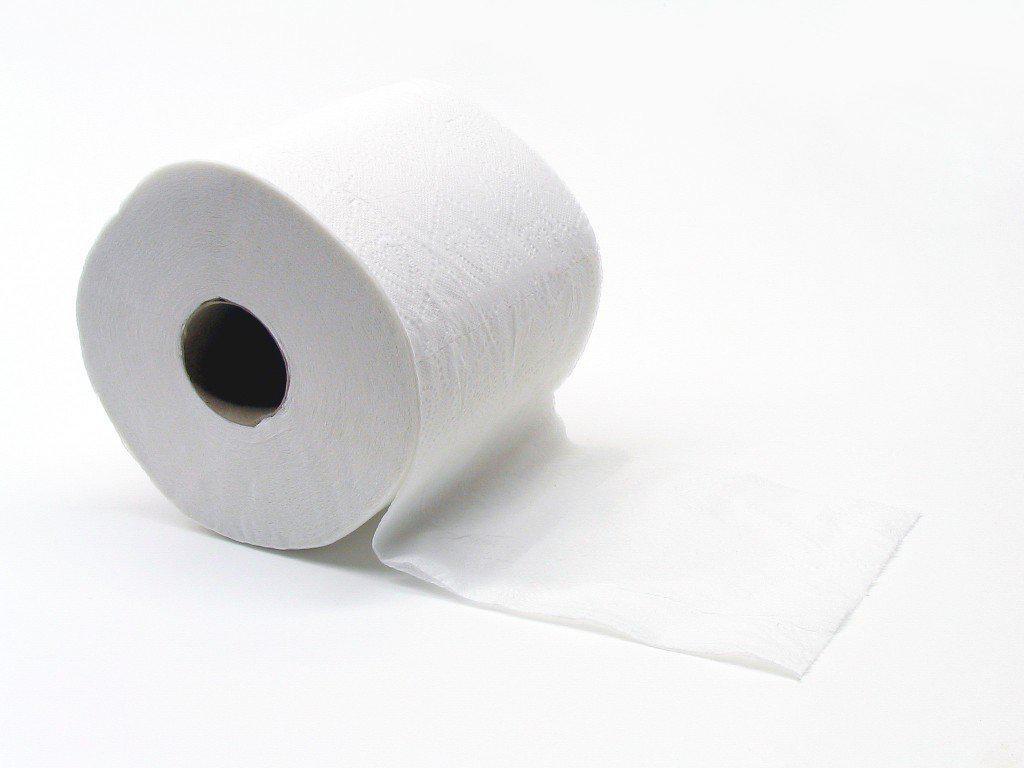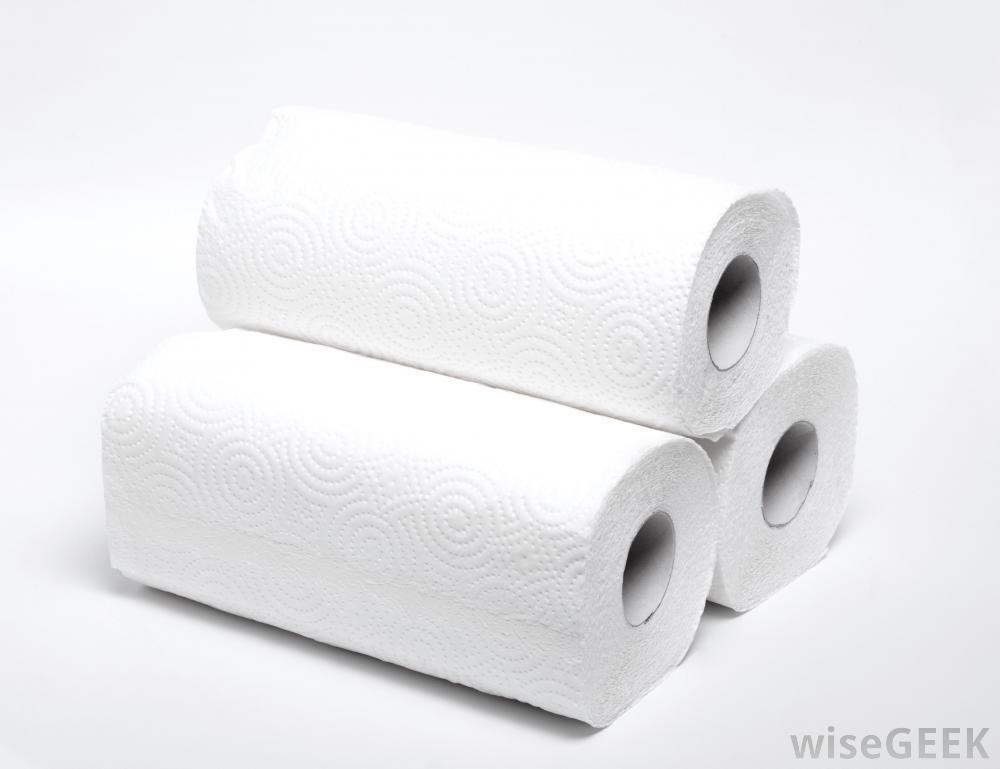The first image is the image on the left, the second image is the image on the right. Evaluate the accuracy of this statement regarding the images: "An image shows one upright roll of paper towels the color of brown craft paper.". Is it true? Answer yes or no. No. The first image is the image on the left, the second image is the image on the right. Given the left and right images, does the statement "An image contains a roll of brown paper towels." hold true? Answer yes or no. No. 